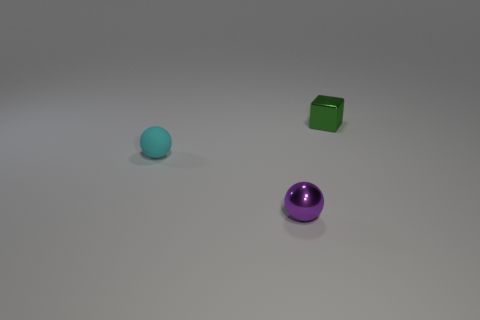Are there fewer tiny rubber balls that are behind the small rubber thing than large red cylinders?
Keep it short and to the point. No. What material is the thing that is in front of the small sphere behind the sphere in front of the small matte ball?
Offer a very short reply. Metal. How many objects are either small spheres to the left of the tiny metallic ball or small metallic objects that are in front of the cyan ball?
Your answer should be compact. 2. There is another tiny thing that is the same shape as the purple metal thing; what material is it?
Your answer should be compact. Rubber. What number of matte things are either tiny cubes or purple things?
Keep it short and to the point. 0. What is the shape of the green thing that is the same material as the small purple sphere?
Offer a terse response. Cube. What number of big red things have the same shape as the tiny cyan matte thing?
Provide a succinct answer. 0. There is a shiny thing in front of the green cube; does it have the same shape as the thing that is to the left of the tiny purple metallic thing?
Keep it short and to the point. Yes. How many things are either tiny cyan rubber objects or metallic objects that are behind the purple shiny sphere?
Your answer should be very brief. 2. What number of blue matte cubes have the same size as the purple thing?
Your answer should be compact. 0. 